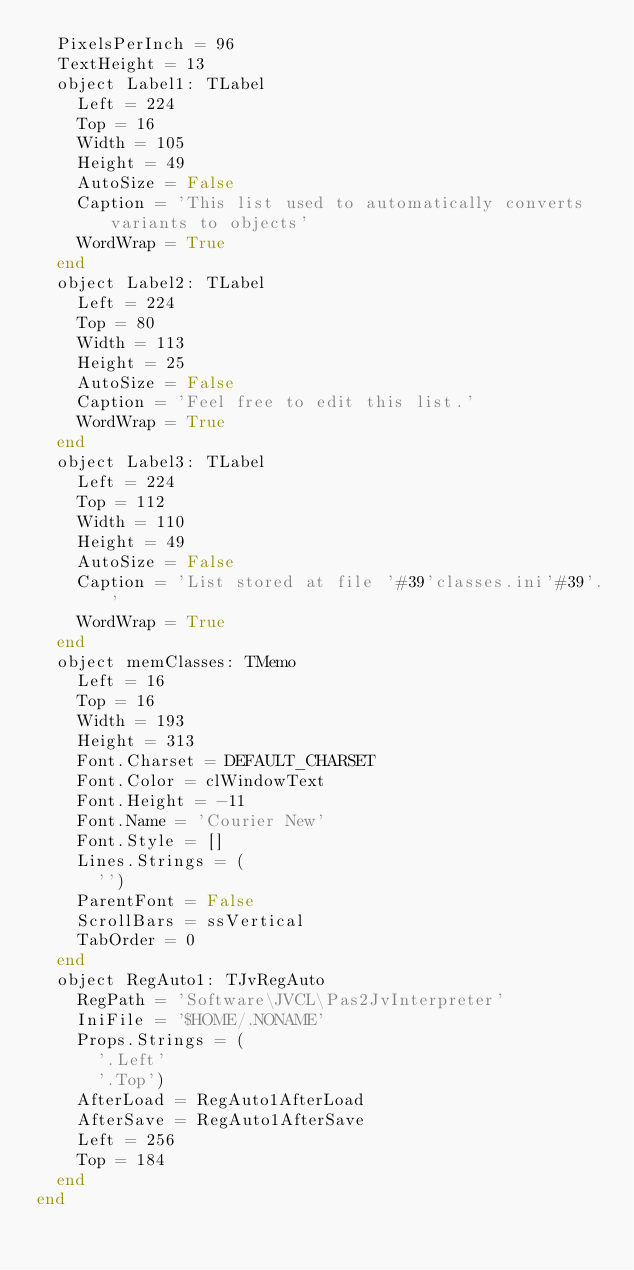<code> <loc_0><loc_0><loc_500><loc_500><_Pascal_>  PixelsPerInch = 96
  TextHeight = 13
  object Label1: TLabel
    Left = 224
    Top = 16
    Width = 105
    Height = 49
    AutoSize = False
    Caption = 'This list used to automatically converts variants to objects'
    WordWrap = True
  end
  object Label2: TLabel
    Left = 224
    Top = 80
    Width = 113
    Height = 25
    AutoSize = False
    Caption = 'Feel free to edit this list.'
    WordWrap = True
  end
  object Label3: TLabel
    Left = 224
    Top = 112
    Width = 110
    Height = 49
    AutoSize = False
    Caption = 'List stored at file '#39'classes.ini'#39'.'
    WordWrap = True
  end
  object memClasses: TMemo
    Left = 16
    Top = 16
    Width = 193
    Height = 313
    Font.Charset = DEFAULT_CHARSET
    Font.Color = clWindowText
    Font.Height = -11
    Font.Name = 'Courier New'
    Font.Style = []
    Lines.Strings = (
      '')
    ParentFont = False
    ScrollBars = ssVertical
    TabOrder = 0
  end
  object RegAuto1: TJvRegAuto
    RegPath = 'Software\JVCL\Pas2JvInterpreter'
    IniFile = '$HOME/.NONAME'
    Props.Strings = (
      '.Left'
      '.Top')
    AfterLoad = RegAuto1AfterLoad
    AfterSave = RegAuto1AfterSave
    Left = 256
    Top = 184
  end
end
</code> 